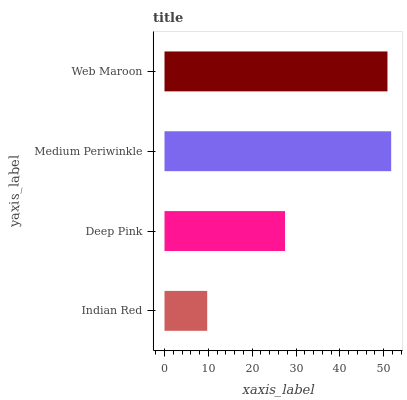Is Indian Red the minimum?
Answer yes or no. Yes. Is Medium Periwinkle the maximum?
Answer yes or no. Yes. Is Deep Pink the minimum?
Answer yes or no. No. Is Deep Pink the maximum?
Answer yes or no. No. Is Deep Pink greater than Indian Red?
Answer yes or no. Yes. Is Indian Red less than Deep Pink?
Answer yes or no. Yes. Is Indian Red greater than Deep Pink?
Answer yes or no. No. Is Deep Pink less than Indian Red?
Answer yes or no. No. Is Web Maroon the high median?
Answer yes or no. Yes. Is Deep Pink the low median?
Answer yes or no. Yes. Is Medium Periwinkle the high median?
Answer yes or no. No. Is Medium Periwinkle the low median?
Answer yes or no. No. 